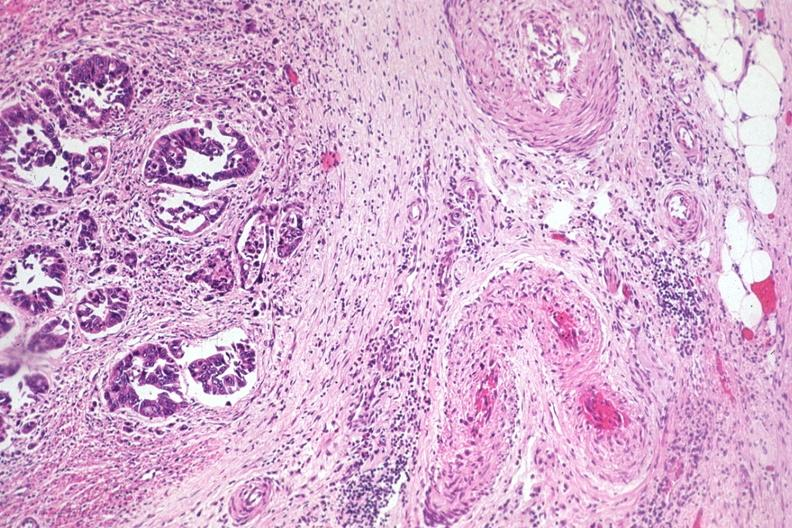what is present?
Answer the question using a single word or phrase. Colon 